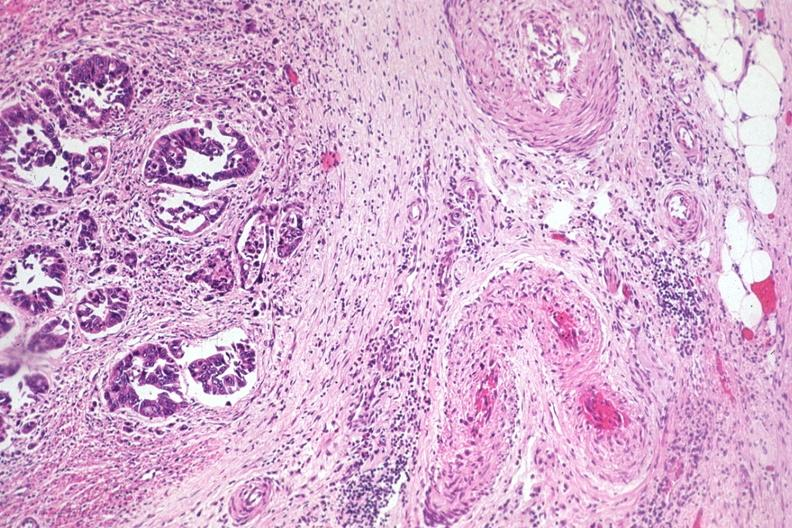what is present?
Answer the question using a single word or phrase. Colon 